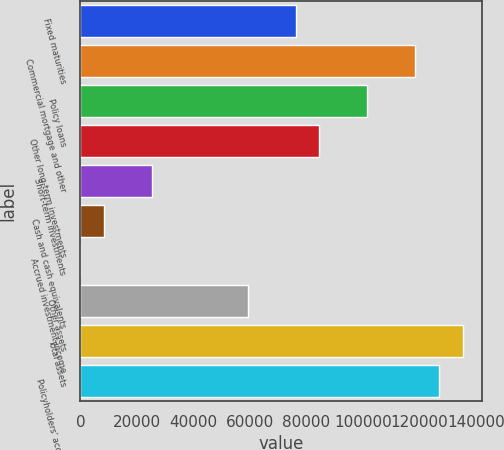<chart> <loc_0><loc_0><loc_500><loc_500><bar_chart><fcel>Fixed maturities<fcel>Commercial mortgage and other<fcel>Policy loans<fcel>Other long-term investments<fcel>Short-term investments<fcel>Cash and cash equivalents<fcel>Accrued investment income<fcel>Other assets<fcel>Total assets<fcel>Policyholders' account<nl><fcel>76149.9<fcel>118455<fcel>101533<fcel>84611<fcel>25383.4<fcel>8461.22<fcel>0.13<fcel>59227.8<fcel>135378<fcel>126916<nl></chart> 